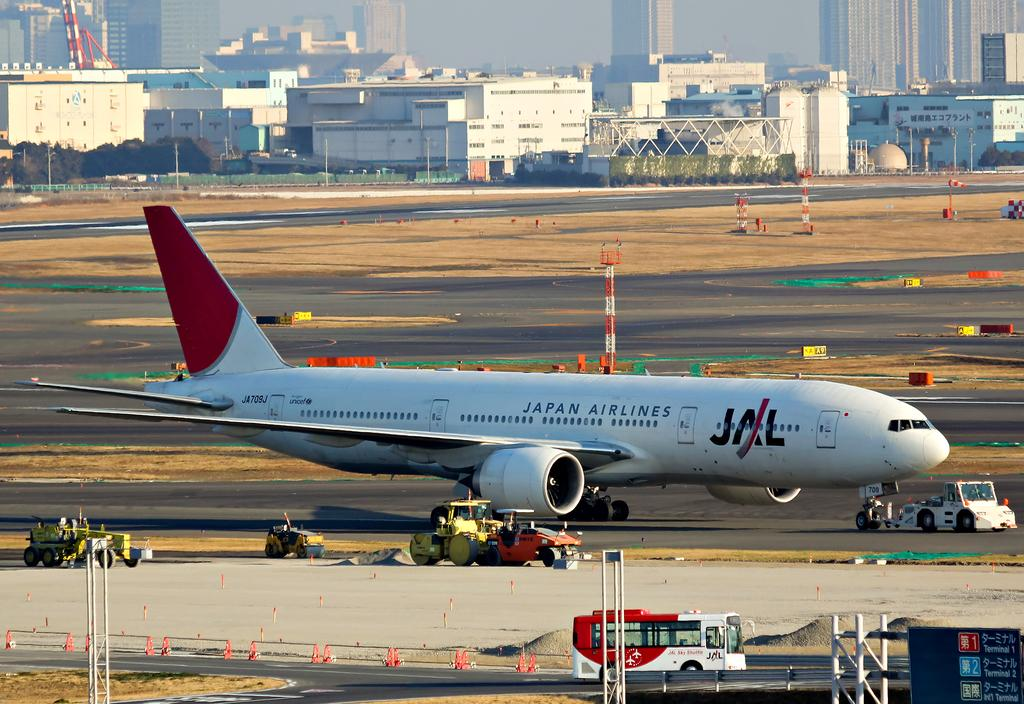Provide a one-sentence caption for the provided image. the letters JAL are on the side of the plane. 